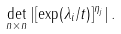Convert formula to latex. <formula><loc_0><loc_0><loc_500><loc_500>\det _ { n \times n } \left | [ \exp ( \lambda _ { i } / t ) ] ^ { \eta _ { j } } \right | .</formula> 